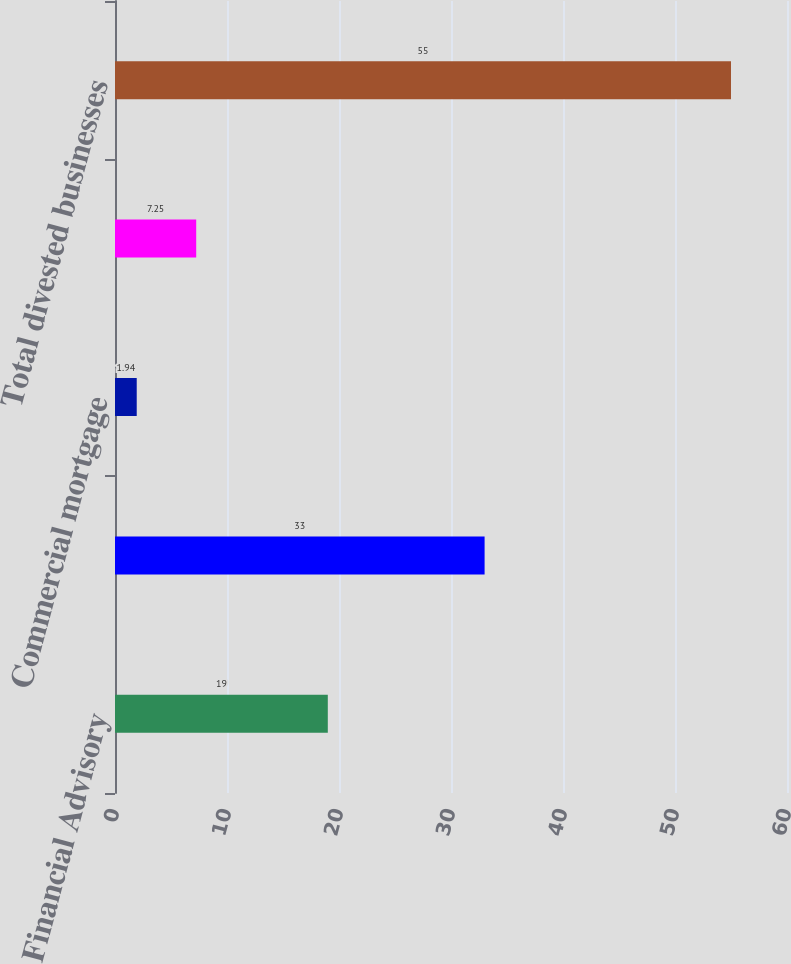<chart> <loc_0><loc_0><loc_500><loc_500><bar_chart><fcel>Financial Advisory<fcel>Property and Casualty<fcel>Commercial mortgage<fcel>Other(1)<fcel>Total divested businesses<nl><fcel>19<fcel>33<fcel>1.94<fcel>7.25<fcel>55<nl></chart> 